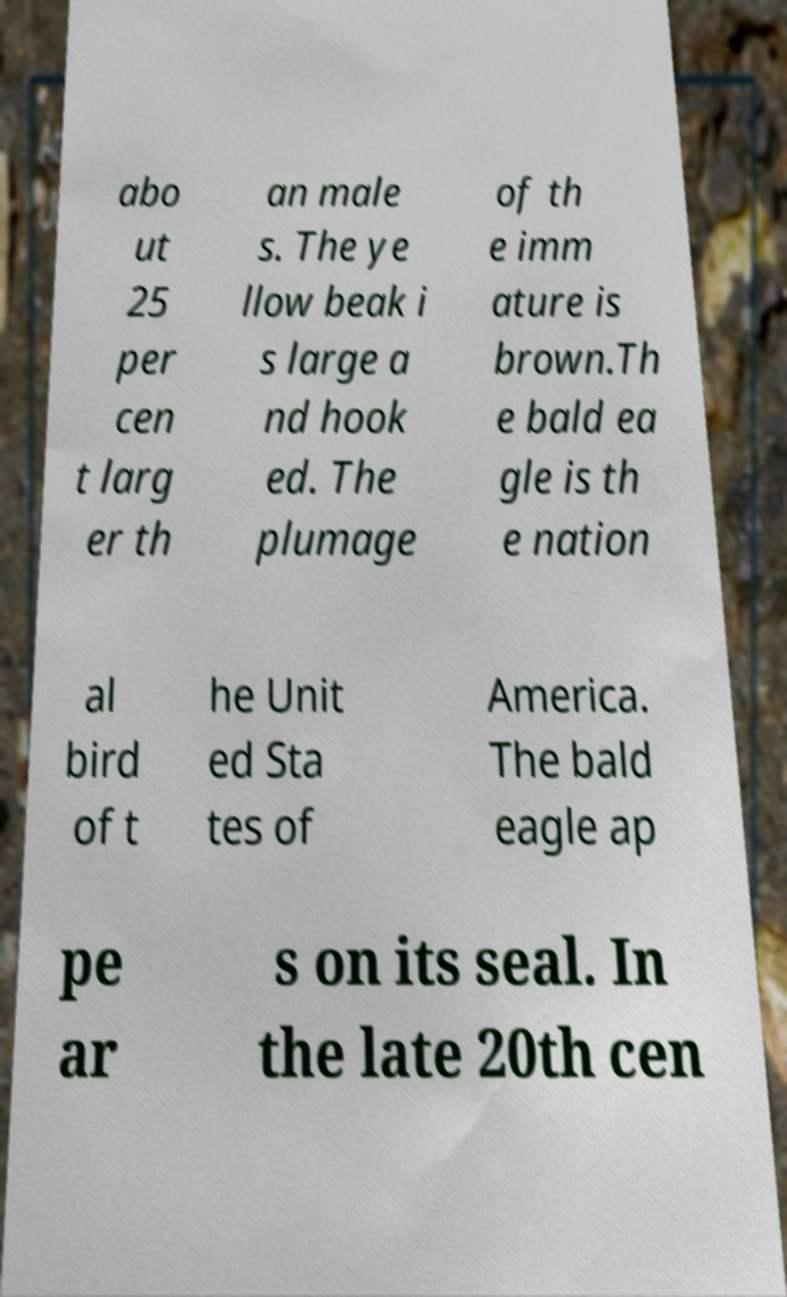Could you assist in decoding the text presented in this image and type it out clearly? abo ut 25 per cen t larg er th an male s. The ye llow beak i s large a nd hook ed. The plumage of th e imm ature is brown.Th e bald ea gle is th e nation al bird of t he Unit ed Sta tes of America. The bald eagle ap pe ar s on its seal. In the late 20th cen 